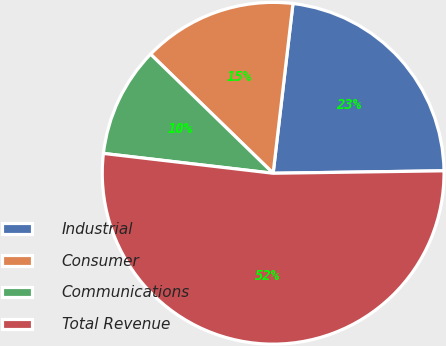Convert chart to OTSL. <chart><loc_0><loc_0><loc_500><loc_500><pie_chart><fcel>Industrial<fcel>Consumer<fcel>Communications<fcel>Total Revenue<nl><fcel>22.92%<fcel>14.58%<fcel>10.42%<fcel>52.08%<nl></chart> 